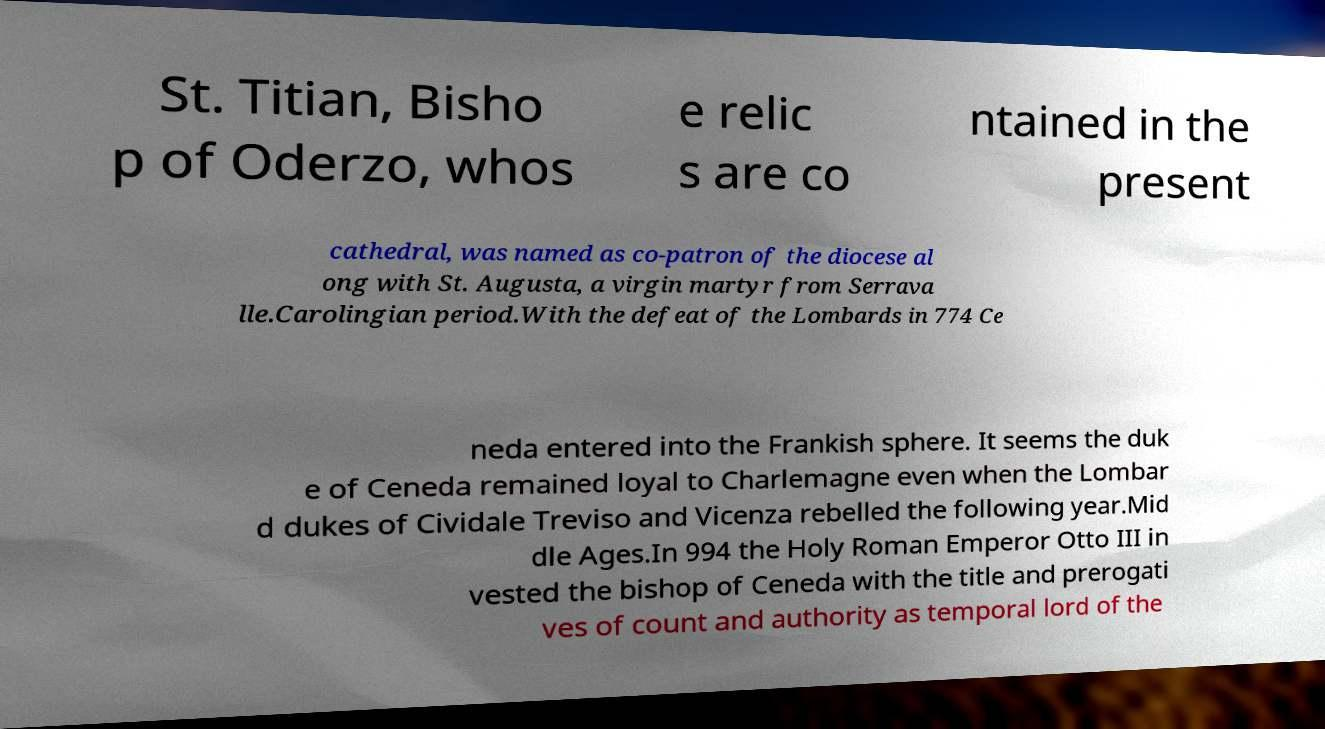I need the written content from this picture converted into text. Can you do that? St. Titian, Bisho p of Oderzo, whos e relic s are co ntained in the present cathedral, was named as co-patron of the diocese al ong with St. Augusta, a virgin martyr from Serrava lle.Carolingian period.With the defeat of the Lombards in 774 Ce neda entered into the Frankish sphere. It seems the duk e of Ceneda remained loyal to Charlemagne even when the Lombar d dukes of Cividale Treviso and Vicenza rebelled the following year.Mid dle Ages.In 994 the Holy Roman Emperor Otto III in vested the bishop of Ceneda with the title and prerogati ves of count and authority as temporal lord of the 